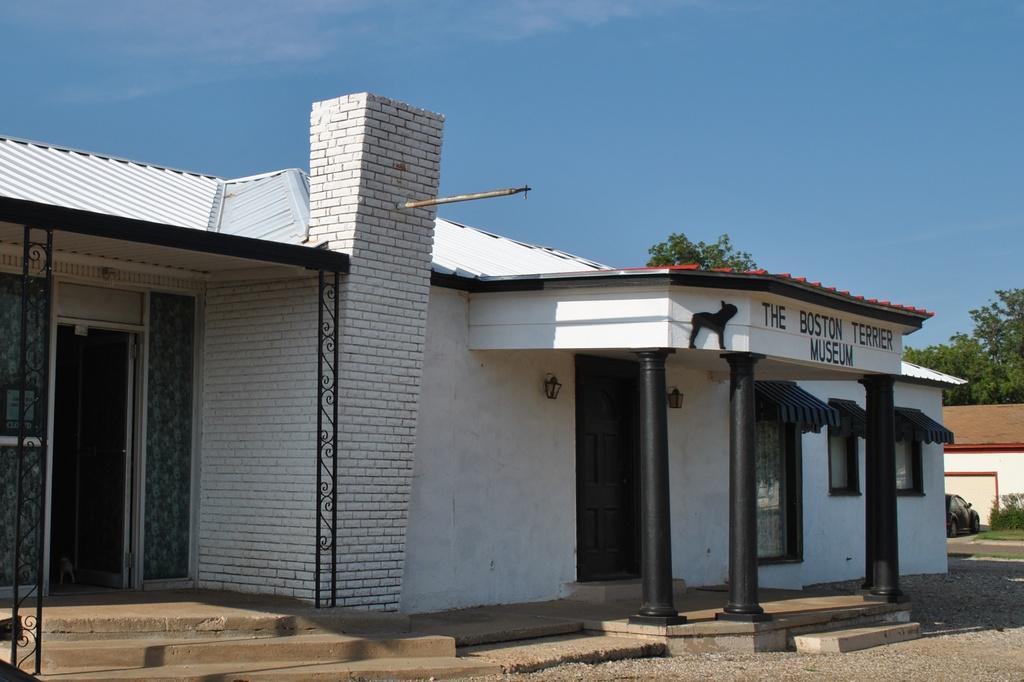In one or two sentences, can you explain what this image depicts? In this image we can see a house with pillars and also stairs at the entrance. We can also see the text and depiction of an animal at the top of the house. On the right there is also another house. We can also see the car, plant, grass, trees and also the path. Sky is also visible. 